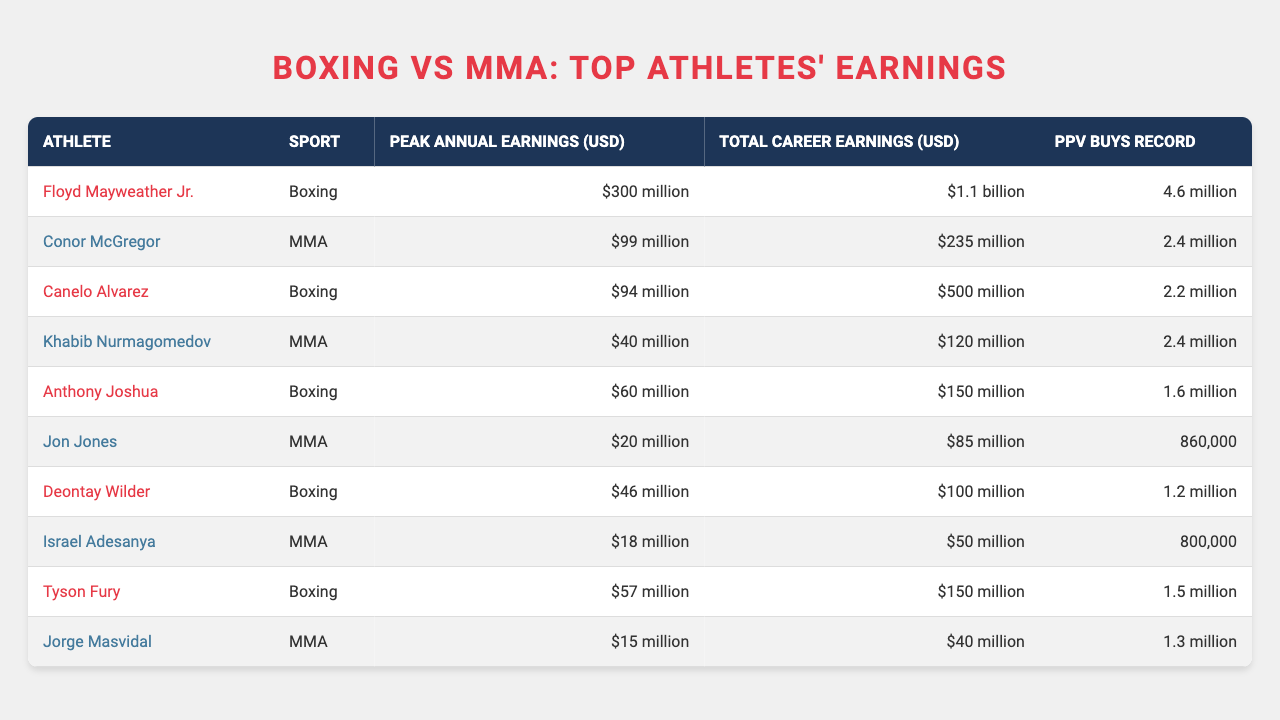What are the peak annual earnings of Floyd Mayweather Jr.? The table shows the data for Floyd Mayweather Jr., indicating that his peak annual earnings are 300 million USD.
Answer: 300 million USD Which sport has the highest total career earnings based on the table? By examining the total career earnings, Floyd Mayweather Jr. in boxing has the highest total at 1.1 billion USD, which is higher than any MMA fighter.
Answer: Boxing How much more did Canelo Alvarez earn in total career earnings than Conor McGregor? Canelo Alvarez has total career earnings of 500 million USD, while Conor McGregor has 235 million USD. The difference is 500 - 235 = 265 million USD.
Answer: 265 million USD Is Jon Jones' peak annual earnings higher than that of Jorge Masvidal? Jon Jones’ peak annual earnings are 20 million USD, while Jorge Masvidal’s peak earnings are 15 million USD. Since 20 million is greater than 15 million, the statement is true.
Answer: Yes What is the average peak annual earnings of the top boxers listed? The peak annual earnings of boxers are 300 million, 94 million, 60 million, 46 million, and 57 million. Summing these gives 300 + 94 + 60 + 46 + 57 = 557 million. The average is 557 / 5 = 111.4 million USD.
Answer: 111.4 million USD Which MMA fighter has the highest PPV buys record? By looking at the PPV buys record in the table, both Conor McGregor and Khabib Nurmagomedov share the highest record of 2.4 million.
Answer: Conor McGregor and Khabib Nurmagomedov What is the total difference in peak annual earnings between the highest boxer and MMA fighter? Floyd Mayweather Jr. has peak earnings of 300 million USD, while Conor McGregor has 99 million USD. The difference is 300 - 99 = 201 million USD.
Answer: 201 million USD Is the total career earnings of Anthony Joshua greater than that of Jon Jones? Anthony Joshua has total career earnings of 150 million USD, whereas Jon Jones has 85 million USD. Since 150 million is greater than 85 million, the answer is yes.
Answer: Yes How many athletes in the table have peak annual earnings over 50 million? The athletes with peak annual earnings over 50 million are Floyd Mayweather Jr., Canelo Alvarez, and Anthony Joshua from boxing, and Conor McGregor from MMA, totaling four athletes.
Answer: 4 What is the range of total career earnings for the fighters listed? The highest total career earnings are 1.1 billion USD (Floyd Mayweather Jr.) and the lowest is 40 million USD (Jorge Masvidal). The range is 1.1 billion - 40 million = 1.06 billion USD.
Answer: 1.06 billion USD 